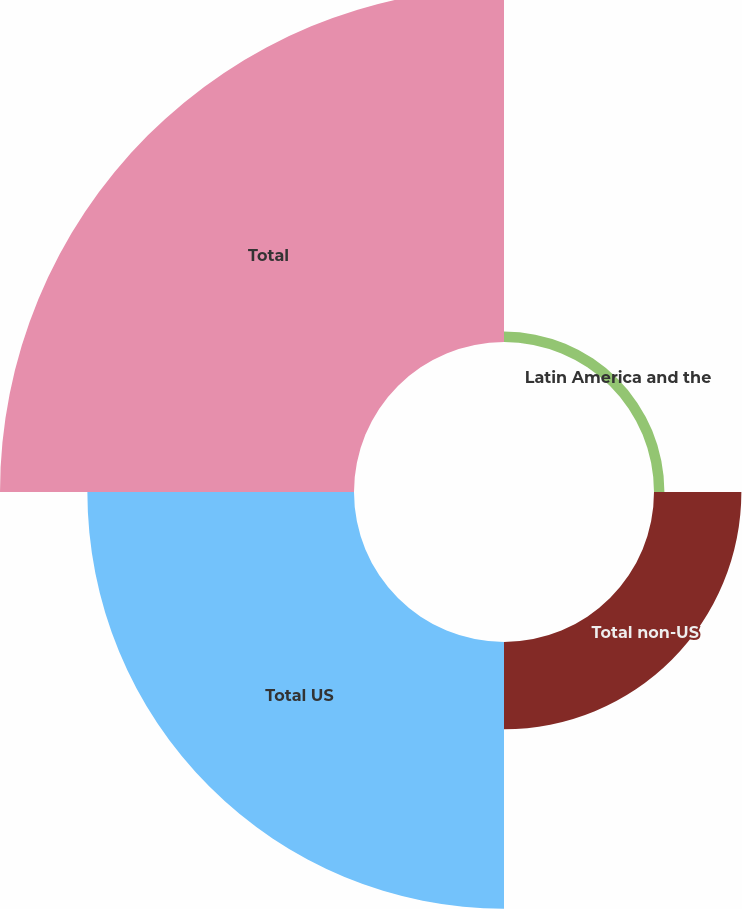Convert chart to OTSL. <chart><loc_0><loc_0><loc_500><loc_500><pie_chart><fcel>Latin America and the<fcel>Total non-US<fcel>Total US<fcel>Total<nl><fcel>1.45%<fcel>12.16%<fcel>37.11%<fcel>49.27%<nl></chart> 